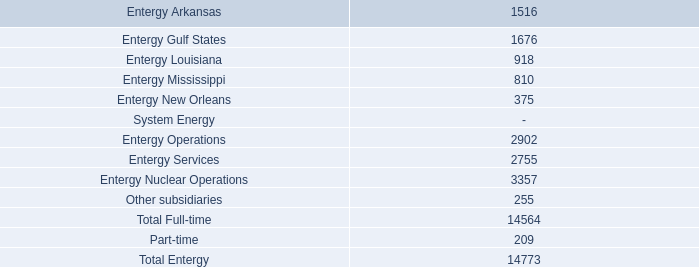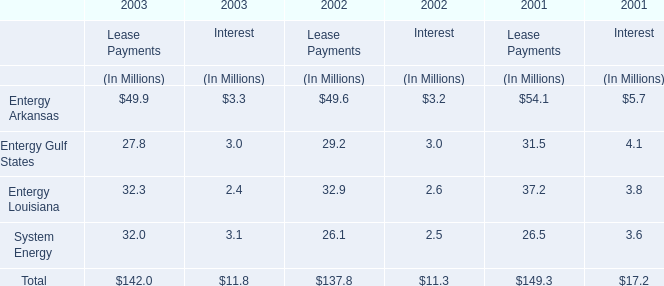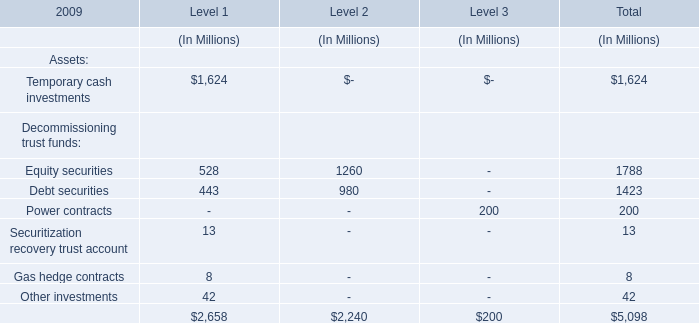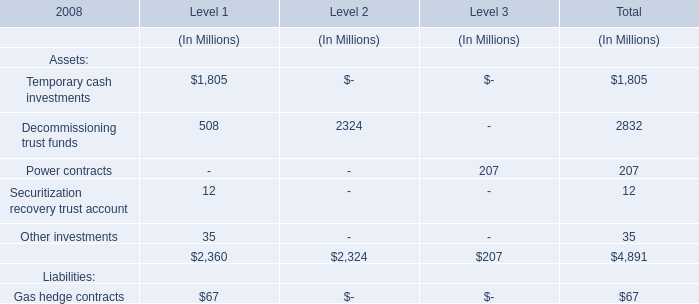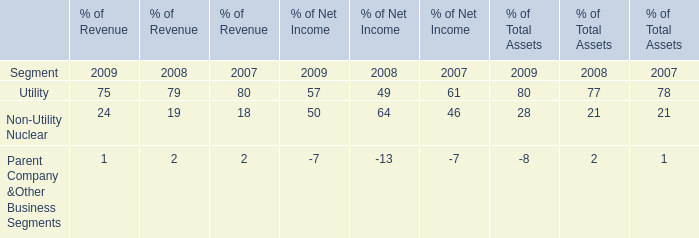What was the average value of Level 1, Level 2, Level 3 forTemporary cash investments ? (in million) 
Computations: (1805 / 3)
Answer: 601.66667. 